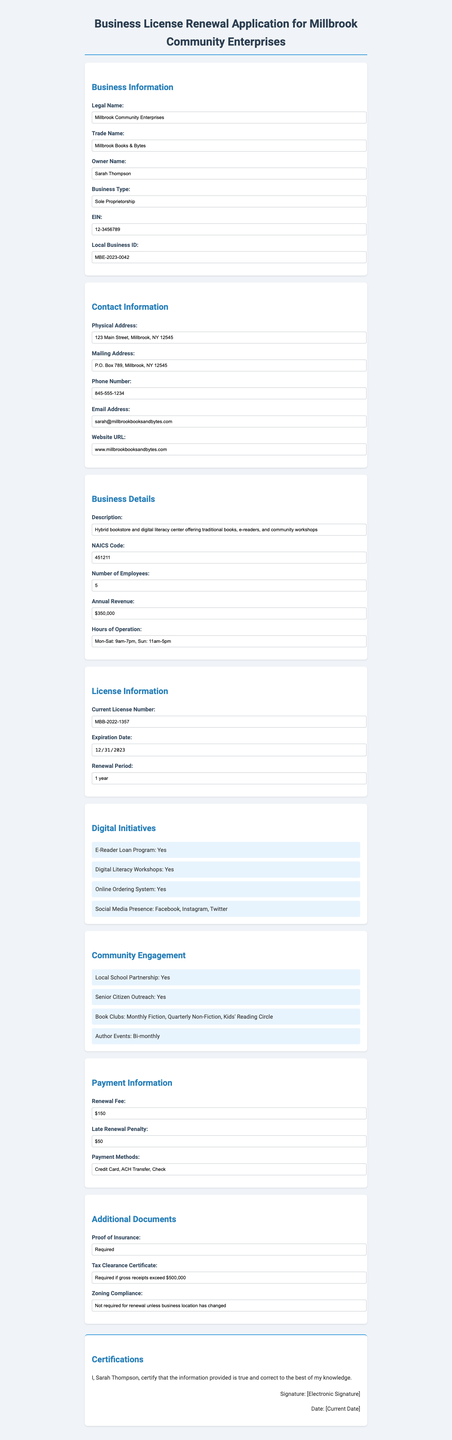what is the legal name of the business? The legal name is provided in the Business Information section of the document.
Answer: Millbrook Community Enterprises what is the trade name of the business? The trade name is listed directly under Business Information.
Answer: Millbrook Books & Bytes how many employees does the business have? The number of employees can be found in the Business Details section.
Answer: 5 when does the current license expire? The expiration date is specified under License Information.
Answer: 2023-12-31 what is the total renewal fee? The renewal fee is mentioned in the Payment Information section.
Answer: $150 which digital initiative is mentioned for enhancing community engagement? Digital initiatives include several programs aimed at community involvement, one of which is specified.
Answer: E-Reader Loan Program how often are author events held? This information can be found under the Community Engagement section, specifying frequency.
Answer: Bi-monthly what is required to renew the business license regarding insurance? The document specifies necessary documentation for renewal in the Additional Documents section.
Answer: Proof of Insurance who is the owner of Millbrook Community Enterprises? The owner's name is provided in the Business Information section.
Answer: Sarah Thompson 